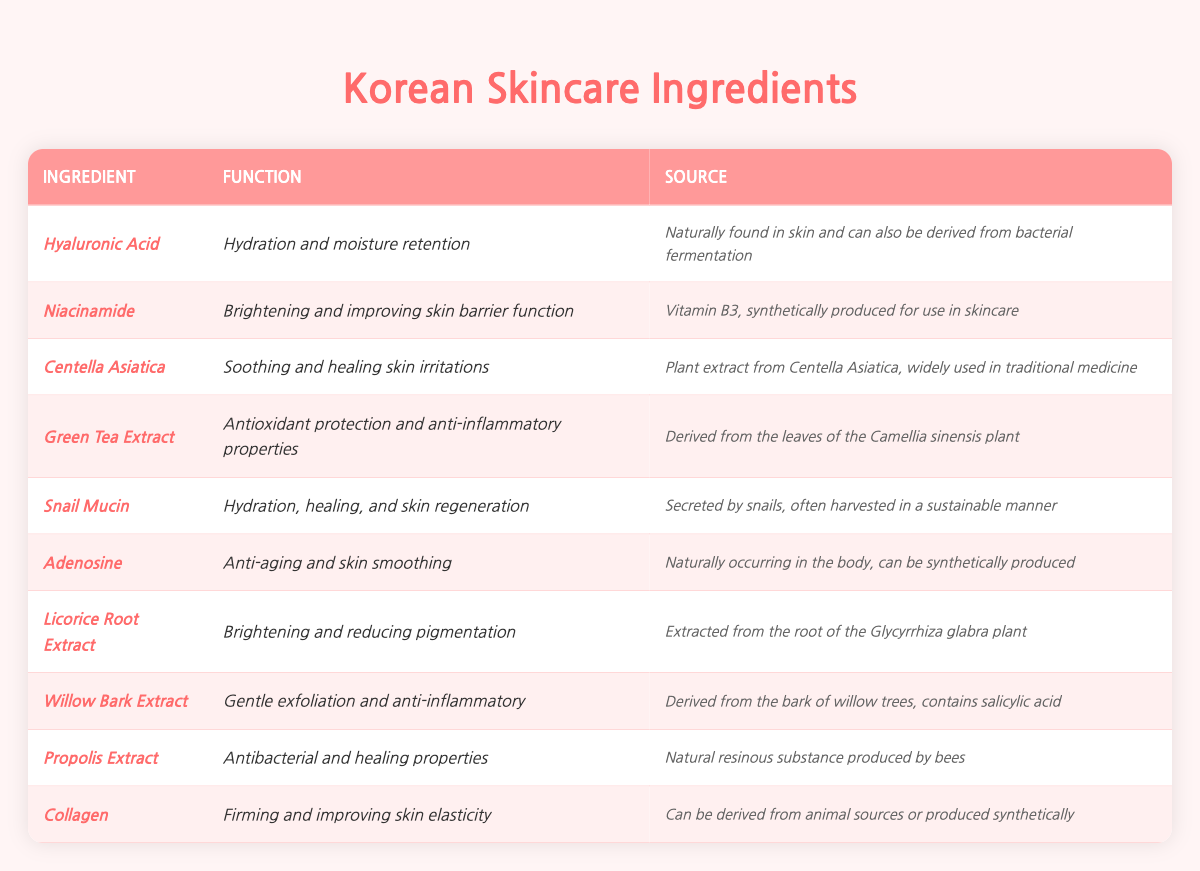What is the function of *Hyaluronic Acid*? The table specifies that *Hyaluronic Acid* is used for *Hydration and moisture retention*.
Answer: Hydration and moisture retention Which ingredient is derived from a plant and is known for its soothing properties? The table lists *Centella Asiatica*, which is identified as a plant extract that soothes and heals skin irritations.
Answer: Centella Asiatica Is *Adenosine* synthetically produced? According to the source in the table, *Adenosine* can be synthetically produced, confirming that the answer is yes.
Answer: Yes Which ingredient contains salicylic acid for gentle exfoliation? The table indicates that *Willow Bark Extract* is derived from willow trees and contains salicylic acid, which is known for gentle exfoliation.
Answer: Willow Bark Extract List two ingredients that are used for brightening the skin. The table shows that both *Niacinamide* and *Licorice Root Extract* are mentioned for their brightening properties.
Answer: Niacinamide and Licorice Root Extract What is the main function of *Propolis Extract*? The table specifies that *Propolis Extract* has antibacterial properties and aids in healing, summarizing its primary function.
Answer: Antibacterial and healing properties How many ingredients listed are derived from animal sources? Referring to the table, only two ingredients (*Snail Mucin* and *Collagen*) are indicated as being derived from animal sources, so we sum them to get the total.
Answer: 2 Which ingredient is primarily known for its anti-aging benefits? The table highlights *Adenosine* as the ingredient known for its anti-aging and skin smoothing properties.
Answer: Adenosine What is the source of *Green Tea Extract*? The table specifies that *Green Tea Extract* is derived from the leaves of the *Camellia sinensis* plant.
Answer: Leaves of the *Camellia sinensis* plant Which ingredient has a function related to skin regeneration? Based on the table, *Snail Mucin* is noted for its role in hydration, healing, and skin regeneration.
Answer: Snail Mucin Combine the functions of *Niacinamide* and *Licorice Root Extract* to describe their combined benefits. The table states that *Niacinamide* is for *Brightening* and improving skin barrier function, while *Licorice Root Extract* also offers brightening and reduces pigmentation. Thus, their combined benefits focus on brightening the skin and enhancing its barrier function.
Answer: Brightening and skin barrier enhancement Is *Green Tea Extract* known for its anti-inflammatory properties? The table confirms that *Green Tea Extract* has anti-inflammatory properties, therefore the answer is yes.
Answer: Yes What type of extract is *Propolis Extract* and what is its main function? The table specifies *Propolis Extract* as a natural resinous substance produced by bees and its main functions are antibacterial and healing properties.
Answer: Natural resinous substance; antibacterial and healing properties Which ingredient functions in both hydration and skin regeneration? The table indicates that *Snail Mucin* serves both functions of hydration and skin regeneration.
Answer: Snail Mucin 